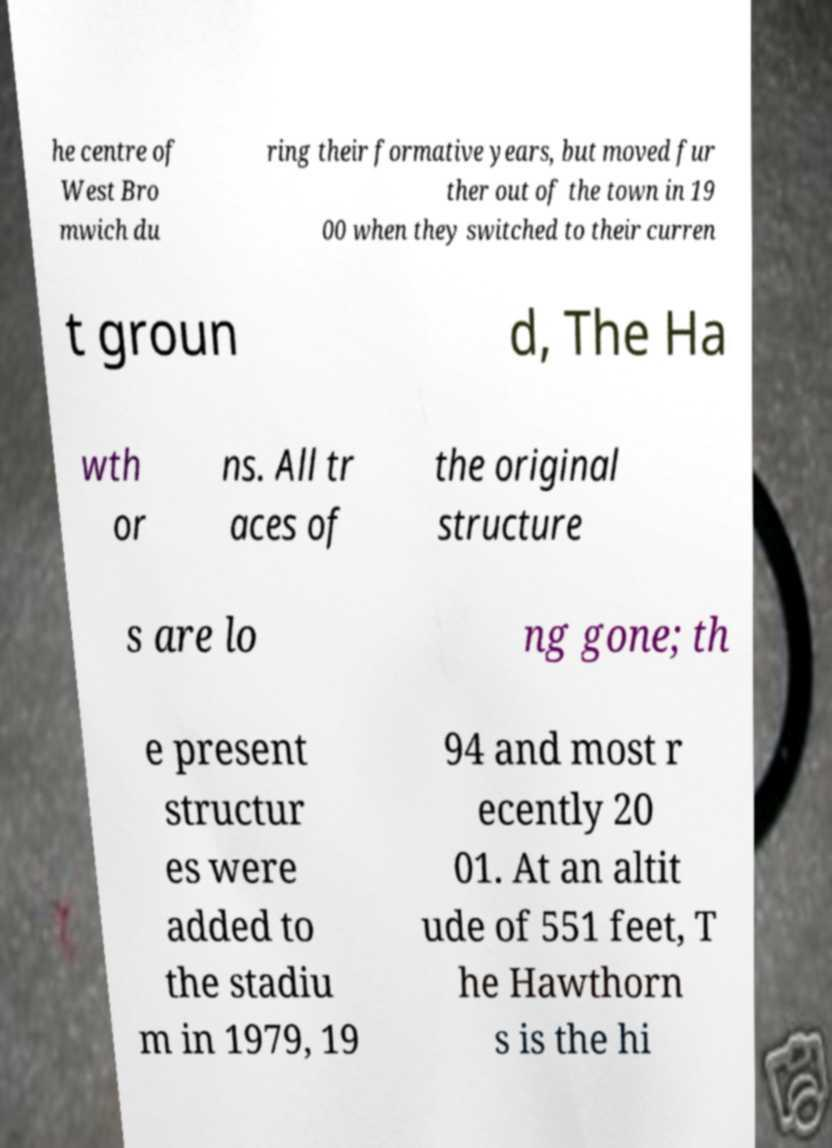For documentation purposes, I need the text within this image transcribed. Could you provide that? he centre of West Bro mwich du ring their formative years, but moved fur ther out of the town in 19 00 when they switched to their curren t groun d, The Ha wth or ns. All tr aces of the original structure s are lo ng gone; th e present structur es were added to the stadiu m in 1979, 19 94 and most r ecently 20 01. At an altit ude of 551 feet, T he Hawthorn s is the hi 